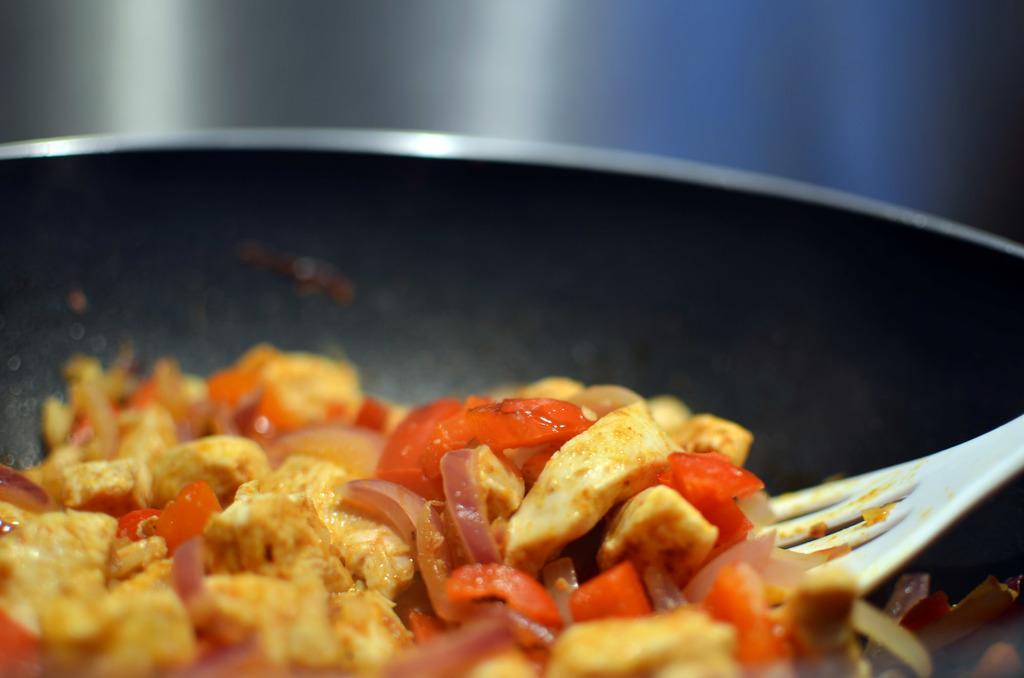Please provide a concise description of this image. In this image I can see a black colored pan and in the pan I can see a food item which is yellow, red and cream in color and the white colored spoon. I can see the blurry background. 